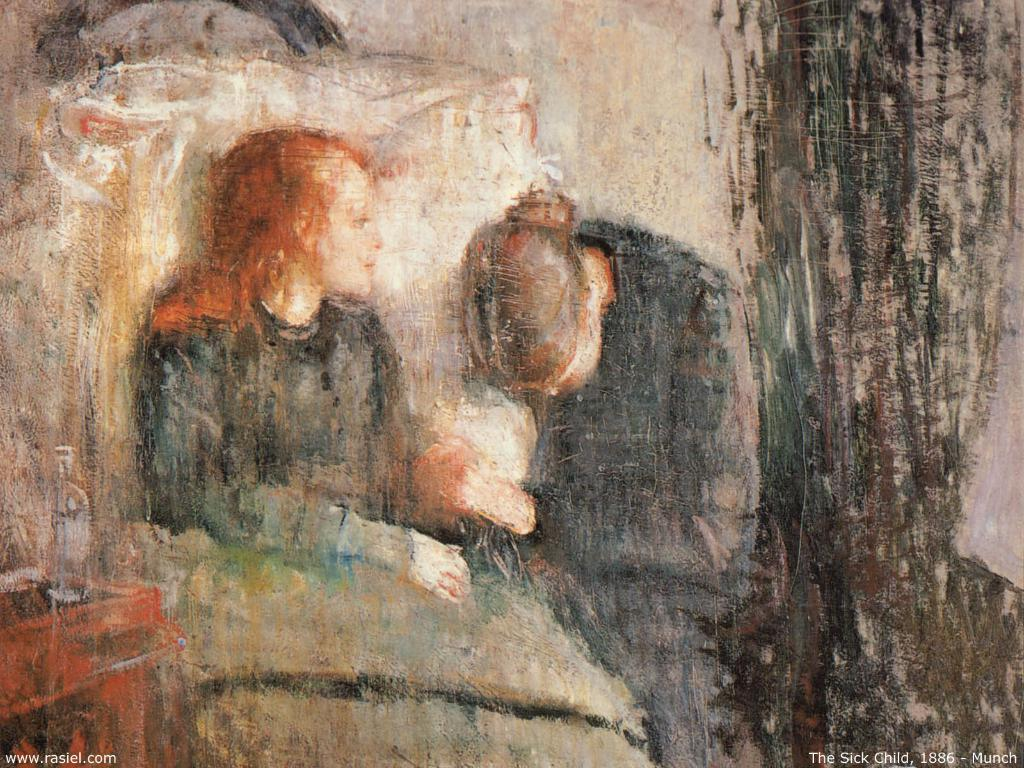What type of artwork is depicted in the image? The image is a painting. How many people are in the painting? There are two persons in the painting. What can be seen on the left side of the painting? There is a desk on the left side of the painting. What object is on the desk in the painting? There is a bottle on the desk in the painting. Can you tell me how many firemen are visible in the painting? There are no firemen present in the painting; it features two persons and a desk with a bottle. Are there any beds visible in the painting? There are no beds present in the painting; it features two persons, a desk, and a bottle. 